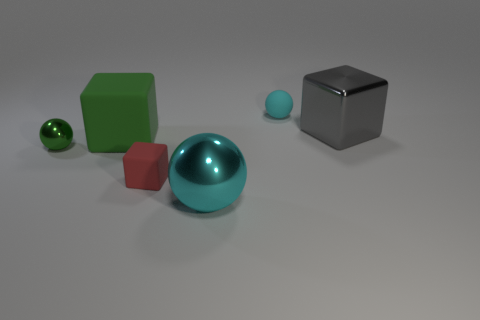There is a large gray object that is made of the same material as the green sphere; what shape is it?
Your answer should be very brief. Cube. The gray object is what size?
Your answer should be very brief. Large. Is the cyan rubber ball the same size as the green ball?
Your answer should be compact. Yes. What number of objects are either blocks in front of the green block or big shiny things that are in front of the small red object?
Make the answer very short. 2. There is a sphere in front of the tiny sphere left of the tiny cyan ball; what number of objects are to the right of it?
Your answer should be compact. 2. There is a cyan ball that is in front of the tiny red block; what is its size?
Give a very brief answer. Large. How many purple blocks have the same size as the red object?
Offer a very short reply. 0. There is a gray metallic block; is it the same size as the matte cube that is to the right of the green rubber cube?
Offer a very short reply. No. What number of things are large yellow balls or metallic spheres?
Your response must be concise. 2. What number of matte things are the same color as the big ball?
Provide a succinct answer. 1. 